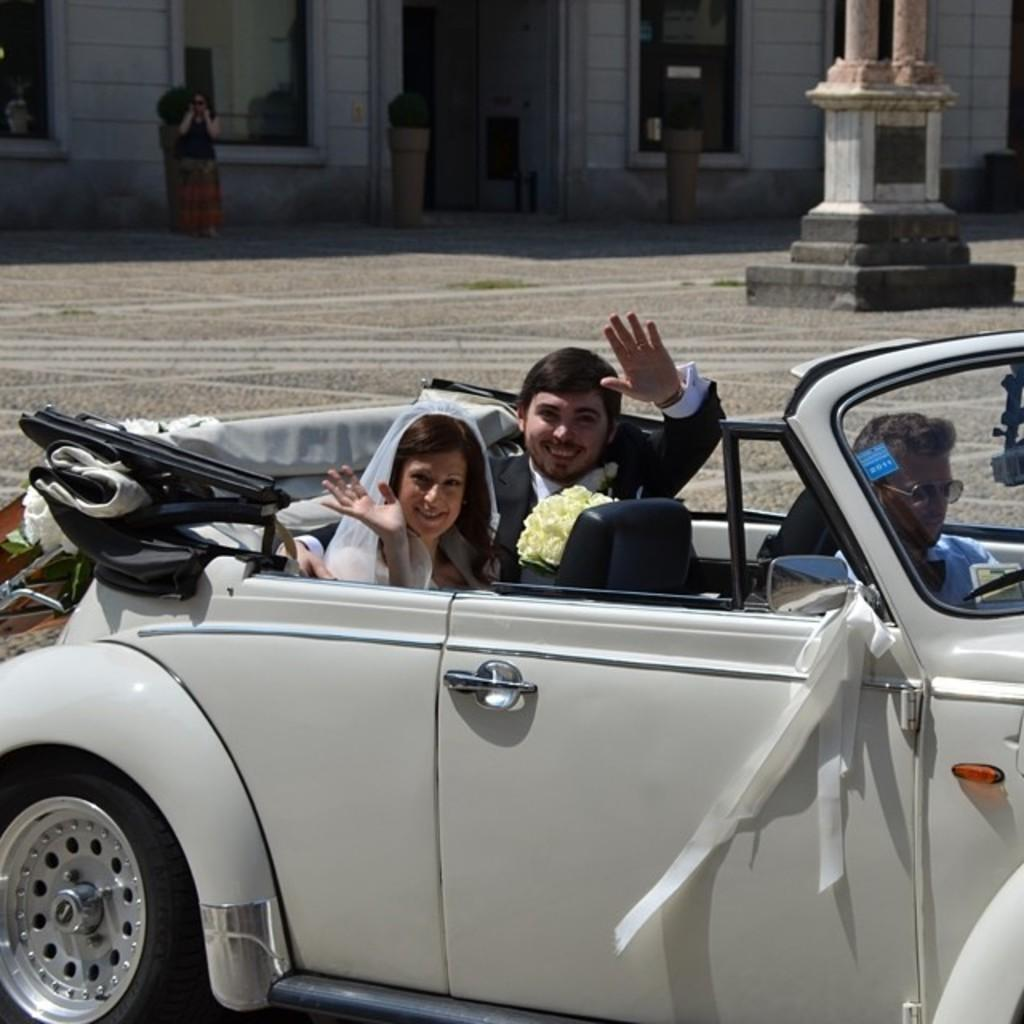Who is present in the image? There is a man and a woman in the image. What are the man and woman doing in the image? The man and woman are sitting on a car and smiling. What can be seen in the background of the image? There is a road, women, a wall, and a window in the background of the image. What type of bell can be seen hanging from the wall in the image? There is no bell present in the image; only a wall and a window are visible in the background. 